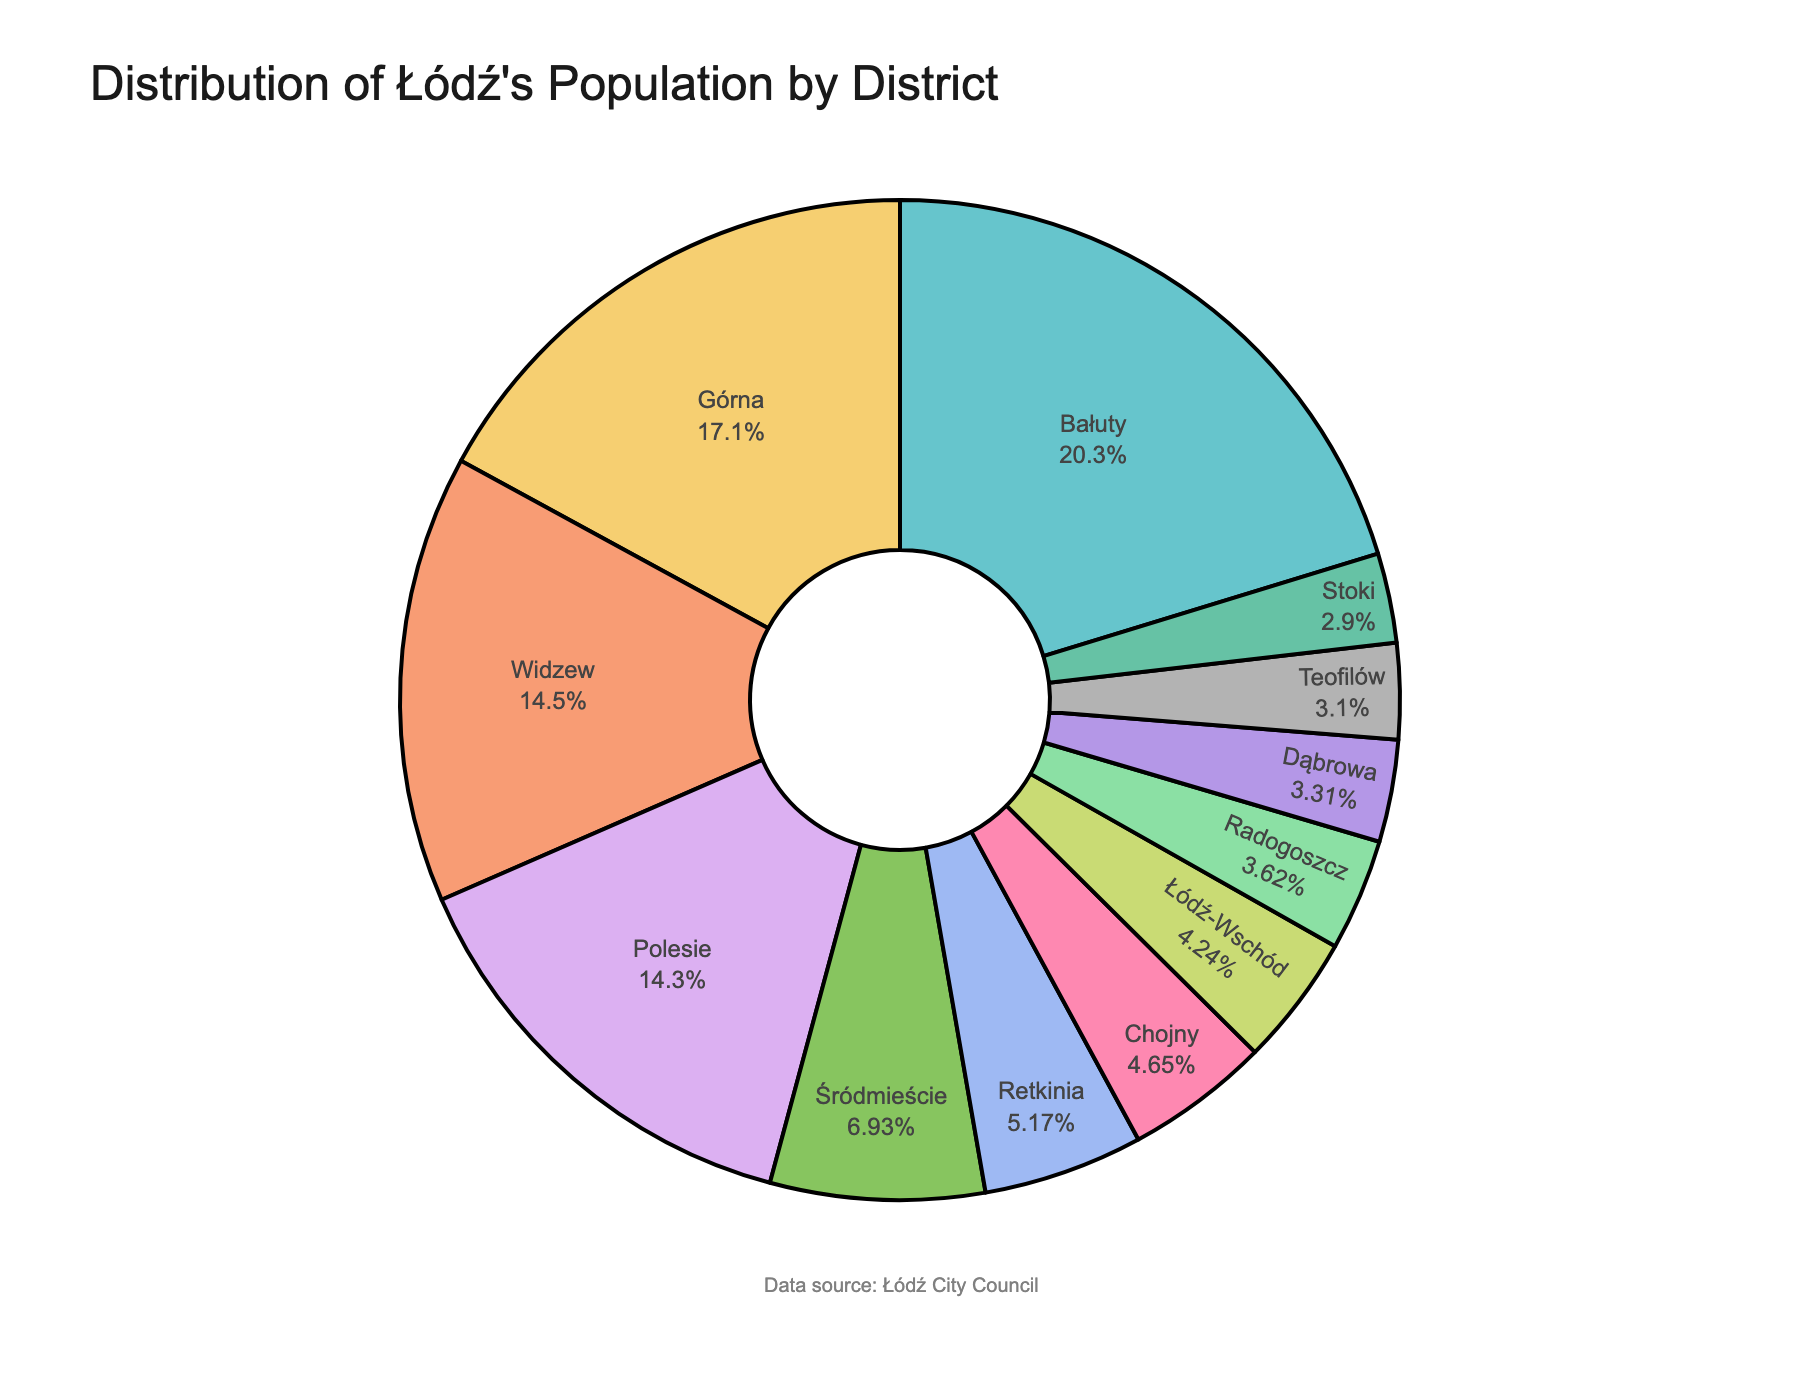What's the largest district by population? The largest slice of the pie chart represents the district with the largest population. Bałuty is the largest district.
Answer: Bałuty Which district has the smallest population? The smallest slice of the pie chart represents the district with the smallest population. Łódź-Wschód is the smallest.
Answer: Łódź-Wschód What percentage of the total population lives in Górna? Locate the Górna section in the pie chart. The percentage is displayed inside the segment.
Answer: 20.89% What is the combined population of Teofilów, Retkinia, and Radogoszcz? Sum the populations of Teofilów (30,000), Retkinia (50,000), and Radogoszcz (35,000). 30,000 + 50,000 + 35,000 = 115,000.
Answer: 115,000 How does Widzew's population compare to Polesie's population? Compare the Widzew slice with the Polesie slice in the pie chart. Widzew’s slice is larger than Polesie’s.
Answer: Larger What is the difference in population between Śródmieście and Górna? Subtract Górna’s population (165,000) from Śródmieście’s population (67,000). 165,000 - 67,000 = 98,000.
Answer: 98,000 Which two districts have the closest populations? Identify and compare the segments in the pie chart that appear most similar in size. Polesie (138,000) and Widzew (140,000) have the closest populations.
Answer: Polesie and Widzew What proportion of the population lives in Bałuty compared to the entire city? Locate the Bałuty section in the pie chart and note the percentage displayed.
Answer: 24.80% What is the total population represented in the pie chart? Add up the populations of all the districts. 196,000 + 165,000 + 138,000 + 67,000 + 140,000 + 41,000 + 30,000 + 50,000 + 45,000 + 35,000 + 28,000 + 32,000 = 967,000.
Answer: 967,000 How does the population of Chojny compare to that of Widzew? Compare the Chojny slice with the Widzew slice in the pie chart. Chojny’s slice is smaller than Widzew’s.
Answer: Smaller 